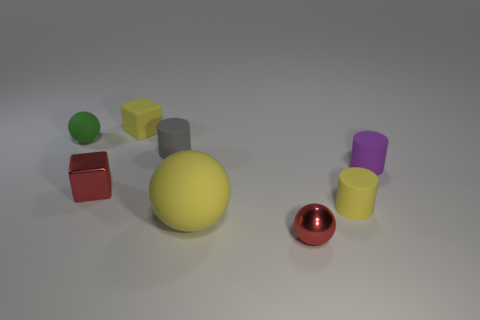Are there fewer small purple shiny cylinders than purple rubber things?
Your answer should be very brief. Yes. The large rubber thing that is the same color as the tiny matte cube is what shape?
Keep it short and to the point. Sphere. There is a small green sphere; how many tiny metallic things are on the right side of it?
Your answer should be compact. 2. Does the gray object have the same shape as the big yellow matte thing?
Offer a very short reply. No. What number of tiny objects are behind the yellow ball and in front of the tiny gray rubber object?
Give a very brief answer. 3. What number of things are either tiny green matte objects or small blocks to the right of the red cube?
Ensure brevity in your answer.  2. Are there more small metal spheres than big blue metal spheres?
Provide a succinct answer. Yes. What shape is the yellow thing that is behind the red metallic block?
Make the answer very short. Cube. What number of large yellow things are the same shape as the small green thing?
Give a very brief answer. 1. There is a shiny object in front of the red thing left of the tiny red ball; how big is it?
Offer a terse response. Small. 